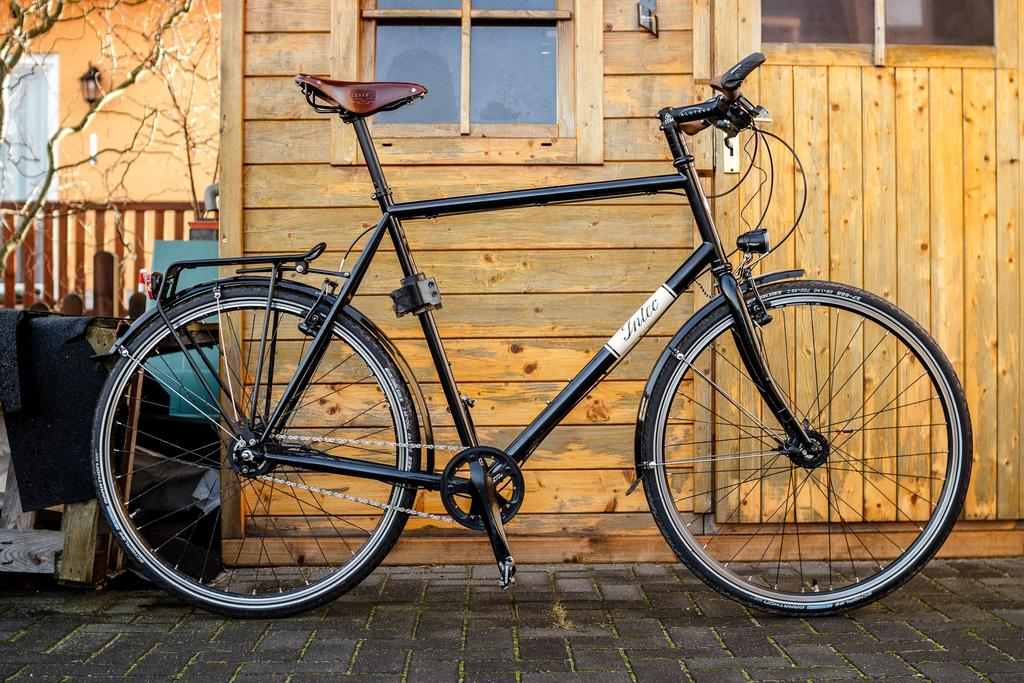What is the main object in the image? There is a bicycle in the image. Where is the bicycle located? The bicycle is parked on the road. What else can be seen in the image besides the bicycle? There is a building in the image. Can you describe the unspecified "things" in the image? Unfortunately, the provided facts do not give any details about the "things" in the image. What type of ring can be seen on the bicycle's handlebars in the image? There is no ring present on the bicycle's handlebars in the image. How many birds are flying above the building in the image? There are no birds visible in the image. 